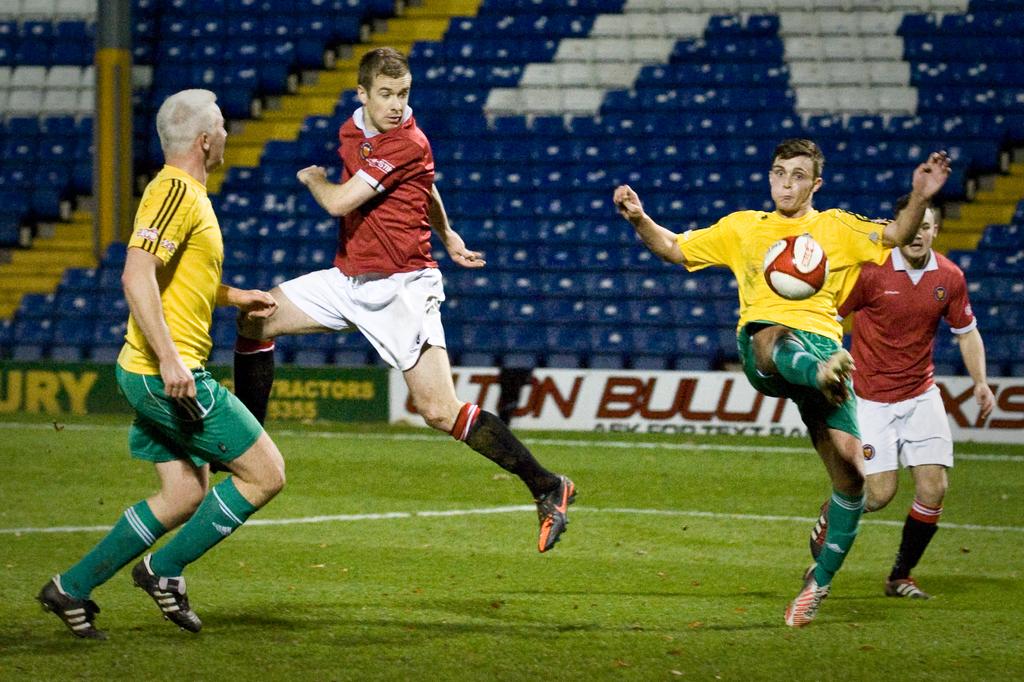What is the red letter to the far right of the image?
Provide a succinct answer. S. What brand are the socks?
Offer a terse response. Adidas. 